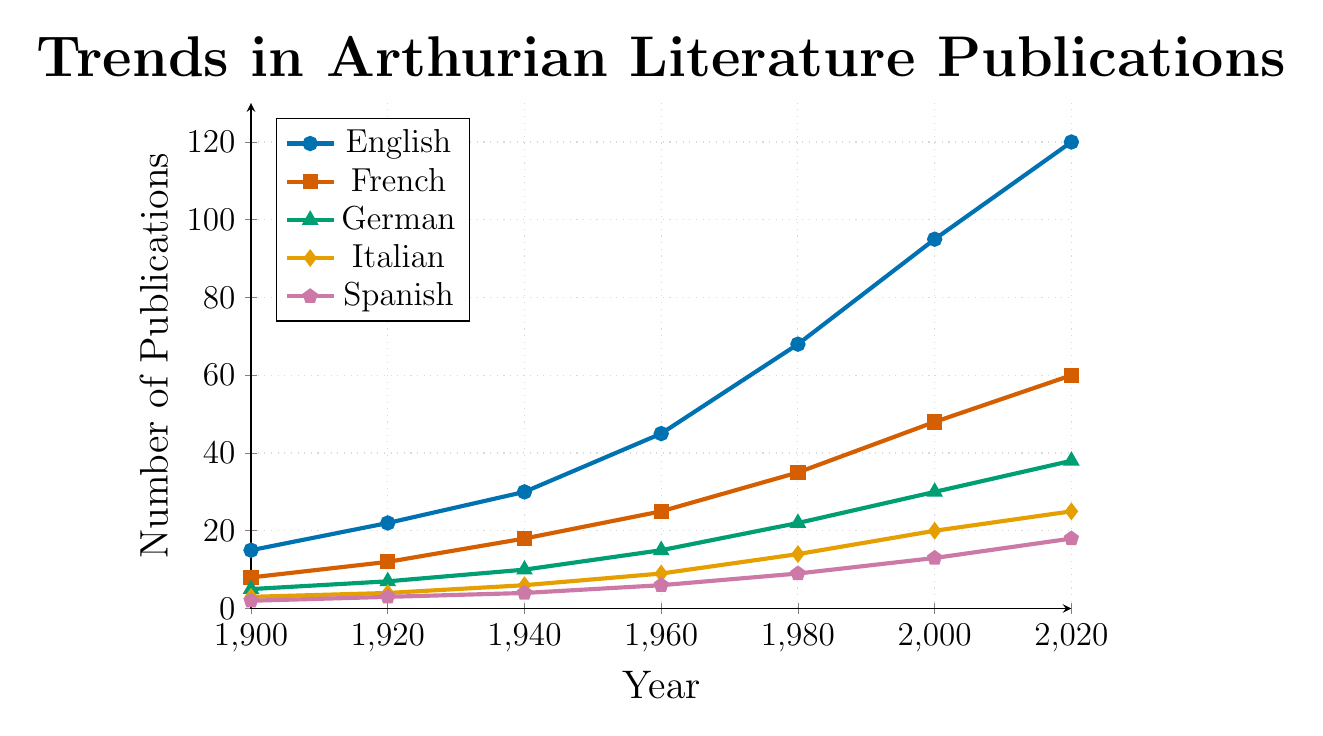Which language had the highest number of publications in 1980? From the figure, observe that the line representing English publications is higher than the others in 1980.
Answer: English How many more publications were there in English than in French in 2020? In 2020, the figure shows 120 publications for English and 60 for French. The difference is 120 - 60.
Answer: 60 What is the average number of German publications across all years? The numbers for German publications are 5, 7, 10, 15, 22, 30, and 38. Sum these numbers: 5 + 7 + 10 + 15 + 22 + 30 + 38 = 127. Then, divide by the number of years (7). So, 127 / 7 ≈ 18.14.
Answer: 18.14 Between which consecutive decades did Italian publications see the greatest increase? Calculate the differences for each decade: (1920 - 1900), (1940 - 1920), (1960 - 1940), (1980 - 1960), (2000 - 1980), and (2020 - 2000). They are 4 - 3 = 1, 6 - 4 = 2, 9 - 6 = 3, 14 - 9 = 5, 20 - 14 = 6, and 25 - 20 = 5. The greatest increase is between 1980 and 2000 with 6.
Answer: 1980 to 2000 What is the sum of all Arthurian literature publications in 2000 across all languages? Sum the values for each language in 2000: 95 (English) + 48 (French) + 30 (German) + 20 (Italian) + 13 (Spanish) = 206.
Answer: 206 Which language's publications grew the most significantly between 1960 and 2020? Calculate the growth for each language: English (120 - 45 = 75), French (60 - 25 = 35), German (38 - 15 = 23), Italian (25 - 9 = 16), Spanish (18 - 6 = 12). English had the most significant growth of 75.
Answer: English What was the trend for Spanish publications from 1900 to 2020? From the figure, observe the slope of the line for Spanish publications. It consistently increases from 2 in 1900 to 18 in 2020.
Answer: Increasing How did the number of French publications in 1940 compare to the number of Italian publications in 2000? The figure shows 18 French publications in 1940 and 20 Italian publications in 2000. Italian publications in 2000 (20) were slightly higher.
Answer: Italian publications were higher Estimate the rate of increase for English publications from 1900 to 2020. The initial value in 1900 was 15, and the final value in 2020 was 120. The increase is 120 - 15 = 105. This occurred over 120 years, so the rate is 105/120 ≈ 0.875 publications per year.
Answer: ~0.875 publications/year What is the ratio of Spanish publications to German publications in 2020? In 2020, Spanish publications are 18 and German publications are 38. The ratio is 18/38, which simplifies to 9/19.
Answer: 9:19 